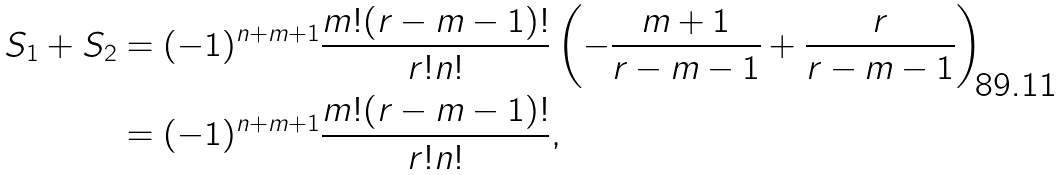<formula> <loc_0><loc_0><loc_500><loc_500>S _ { 1 } + S _ { 2 } & = ( - 1 ) ^ { n + m + 1 } \frac { m ! ( r - m - 1 ) ! } { r ! n ! } \left ( - \frac { m + 1 } { r - m - 1 } + \frac { r } { r - m - 1 } \right ) \\ & = ( - 1 ) ^ { n + m + 1 } \frac { m ! ( r - m - 1 ) ! } { r ! n ! } , \\</formula> 